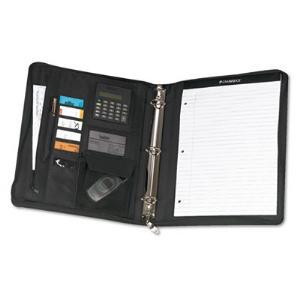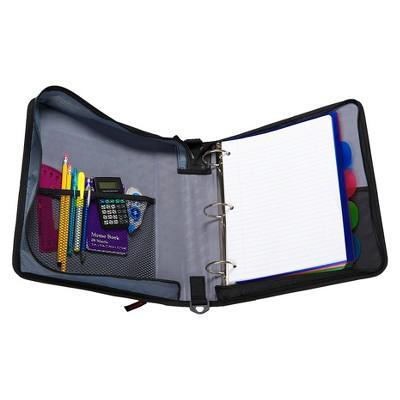The first image is the image on the left, the second image is the image on the right. For the images displayed, is the sentence "Four versions of a binder are standing in a row and overlapping each other." factually correct? Answer yes or no. No. The first image is the image on the left, the second image is the image on the right. Examine the images to the left and right. Is the description "The right image contains at least one open binder and one closed binder." accurate? Answer yes or no. No. 